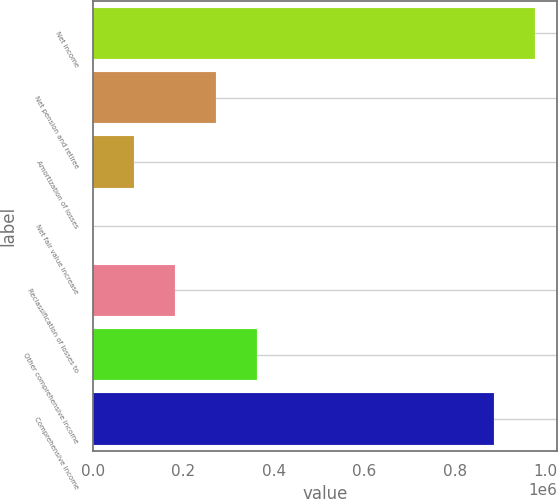Convert chart to OTSL. <chart><loc_0><loc_0><loc_500><loc_500><bar_chart><fcel>Net income<fcel>Net pension and retiree<fcel>Amortization of losses<fcel>Net fair value increase<fcel>Reclassification of losses to<fcel>Other comprehensive income<fcel>Comprehensive income<nl><fcel>977114<fcel>271706<fcel>90699.3<fcel>196<fcel>181203<fcel>362209<fcel>886611<nl></chart> 